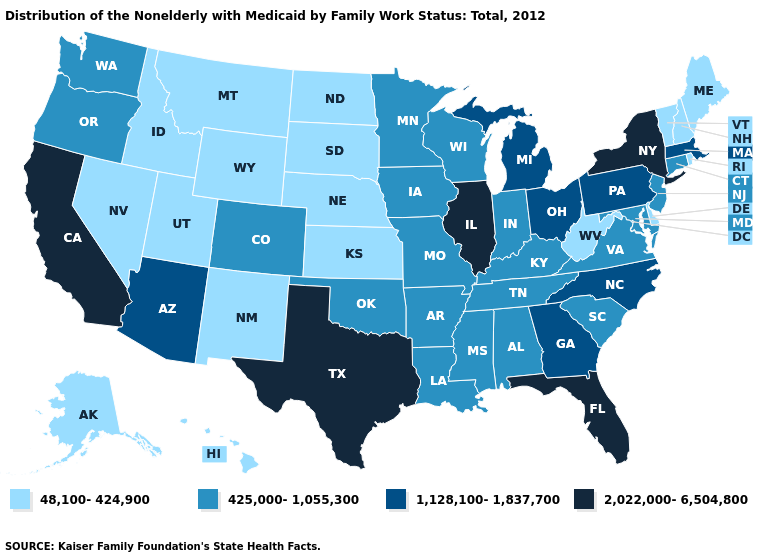Among the states that border Maine , which have the highest value?
Concise answer only. New Hampshire. Does Virginia have the lowest value in the South?
Concise answer only. No. Name the states that have a value in the range 1,128,100-1,837,700?
Give a very brief answer. Arizona, Georgia, Massachusetts, Michigan, North Carolina, Ohio, Pennsylvania. What is the value of West Virginia?
Keep it brief. 48,100-424,900. What is the value of North Carolina?
Give a very brief answer. 1,128,100-1,837,700. Name the states that have a value in the range 425,000-1,055,300?
Short answer required. Alabama, Arkansas, Colorado, Connecticut, Indiana, Iowa, Kentucky, Louisiana, Maryland, Minnesota, Mississippi, Missouri, New Jersey, Oklahoma, Oregon, South Carolina, Tennessee, Virginia, Washington, Wisconsin. What is the value of Mississippi?
Concise answer only. 425,000-1,055,300. Does Texas have the highest value in the USA?
Write a very short answer. Yes. What is the lowest value in the USA?
Be succinct. 48,100-424,900. What is the lowest value in states that border Colorado?
Answer briefly. 48,100-424,900. Which states hav the highest value in the West?
Keep it brief. California. What is the value of New Hampshire?
Write a very short answer. 48,100-424,900. What is the value of Louisiana?
Quick response, please. 425,000-1,055,300. What is the value of Iowa?
Quick response, please. 425,000-1,055,300. Which states have the lowest value in the Northeast?
Concise answer only. Maine, New Hampshire, Rhode Island, Vermont. 